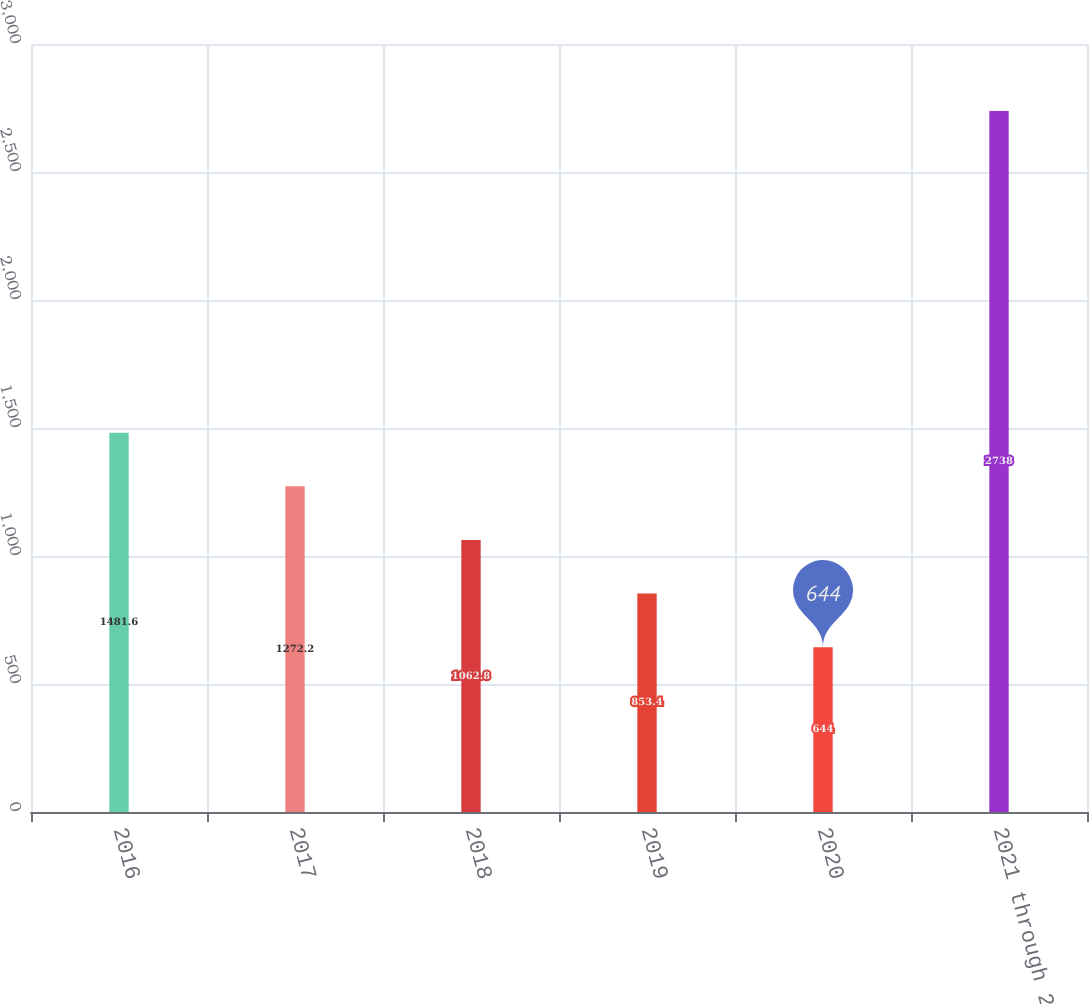<chart> <loc_0><loc_0><loc_500><loc_500><bar_chart><fcel>2016<fcel>2017<fcel>2018<fcel>2019<fcel>2020<fcel>2021 through 2025<nl><fcel>1481.6<fcel>1272.2<fcel>1062.8<fcel>853.4<fcel>644<fcel>2738<nl></chart> 